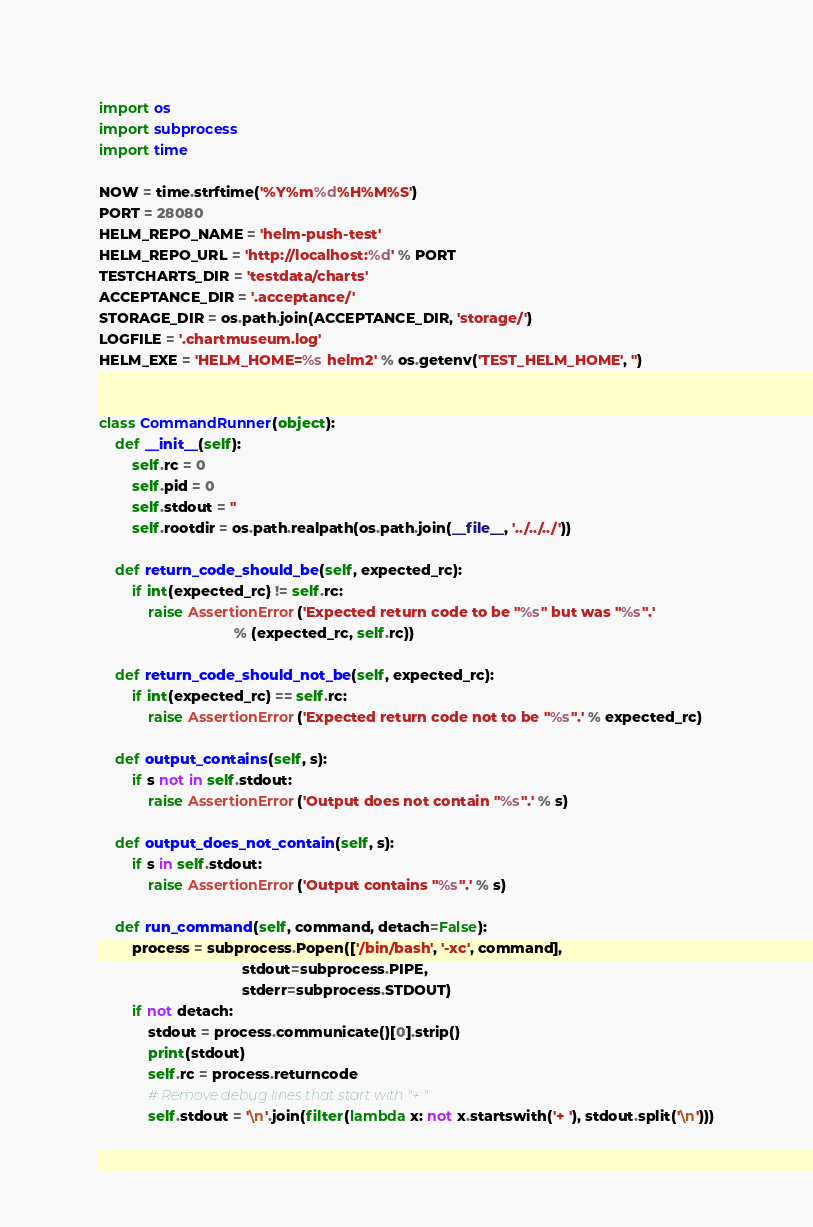<code> <loc_0><loc_0><loc_500><loc_500><_Python_>import os
import subprocess
import time

NOW = time.strftime('%Y%m%d%H%M%S')
PORT = 28080
HELM_REPO_NAME = 'helm-push-test'
HELM_REPO_URL = 'http://localhost:%d' % PORT
TESTCHARTS_DIR = 'testdata/charts'
ACCEPTANCE_DIR = '.acceptance/'
STORAGE_DIR = os.path.join(ACCEPTANCE_DIR, 'storage/')
LOGFILE = '.chartmuseum.log'
HELM_EXE = 'HELM_HOME=%s helm2' % os.getenv('TEST_HELM_HOME', '')


class CommandRunner(object):
    def __init__(self):
        self.rc = 0
        self.pid = 0
        self.stdout = ''
        self.rootdir = os.path.realpath(os.path.join(__file__, '../../../'))

    def return_code_should_be(self, expected_rc):
        if int(expected_rc) != self.rc:
            raise AssertionError('Expected return code to be "%s" but was "%s".'
                                 % (expected_rc, self.rc))

    def return_code_should_not_be(self, expected_rc):
        if int(expected_rc) == self.rc:
            raise AssertionError('Expected return code not to be "%s".' % expected_rc)

    def output_contains(self, s):
        if s not in self.stdout:
            raise AssertionError('Output does not contain "%s".' % s)

    def output_does_not_contain(self, s):
        if s in self.stdout:
            raise AssertionError('Output contains "%s".' % s)

    def run_command(self, command, detach=False):
        process = subprocess.Popen(['/bin/bash', '-xc', command],
                                   stdout=subprocess.PIPE,
                                   stderr=subprocess.STDOUT)
        if not detach:
            stdout = process.communicate()[0].strip()
            print(stdout)
            self.rc = process.returncode
            # Remove debug lines that start with "+ "
            self.stdout = '\n'.join(filter(lambda x: not x.startswith('+ '), stdout.split('\n')))
</code> 